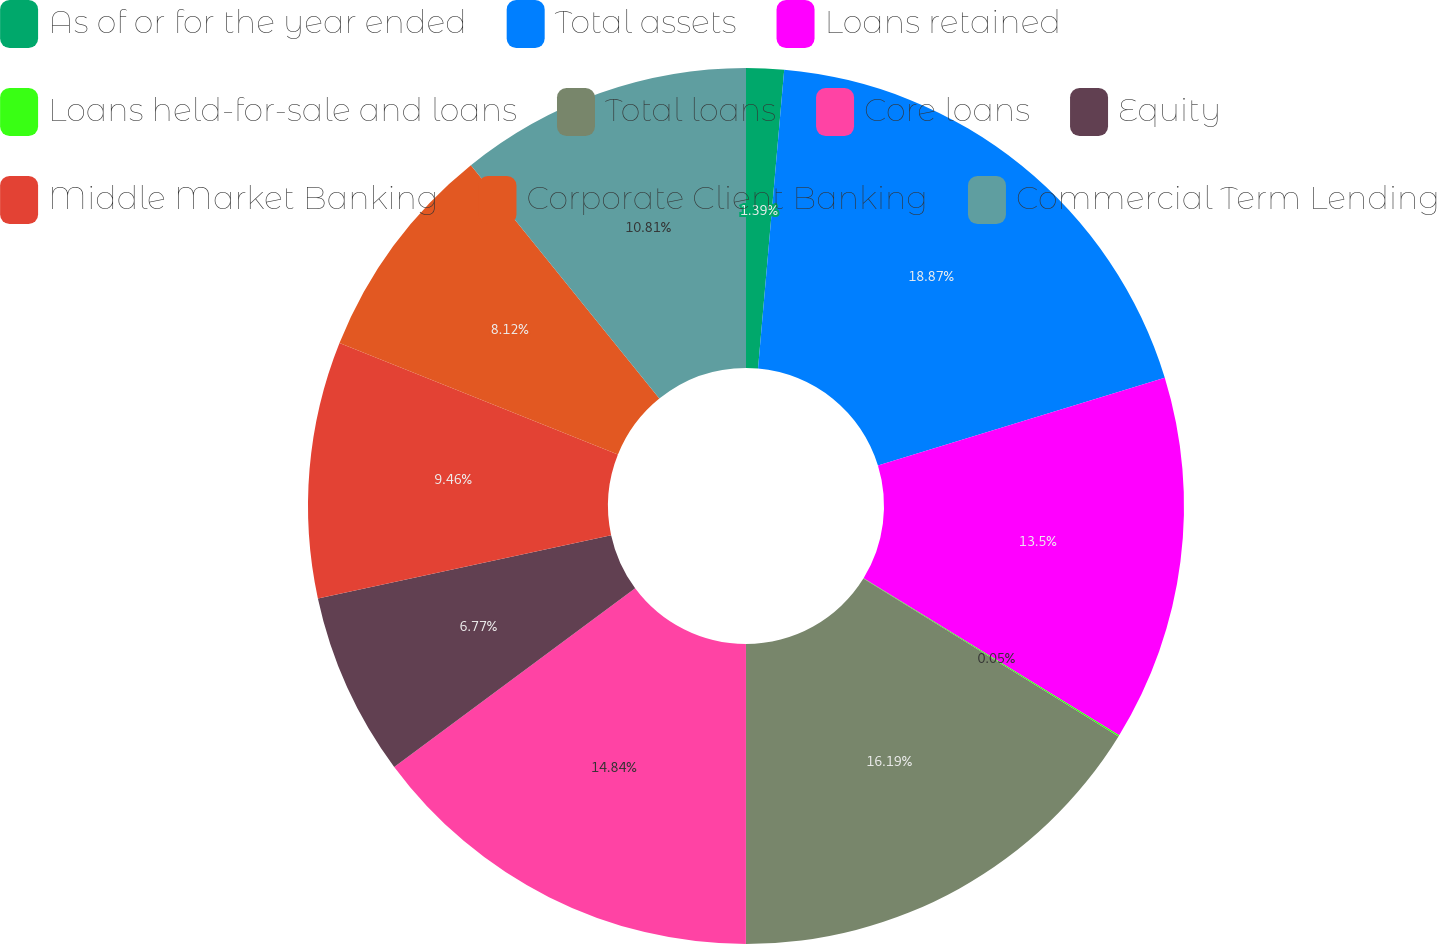Convert chart. <chart><loc_0><loc_0><loc_500><loc_500><pie_chart><fcel>As of or for the year ended<fcel>Total assets<fcel>Loans retained<fcel>Loans held-for-sale and loans<fcel>Total loans<fcel>Core loans<fcel>Equity<fcel>Middle Market Banking<fcel>Corporate Client Banking<fcel>Commercial Term Lending<nl><fcel>1.39%<fcel>18.88%<fcel>13.5%<fcel>0.05%<fcel>16.19%<fcel>14.84%<fcel>6.77%<fcel>9.46%<fcel>8.12%<fcel>10.81%<nl></chart> 